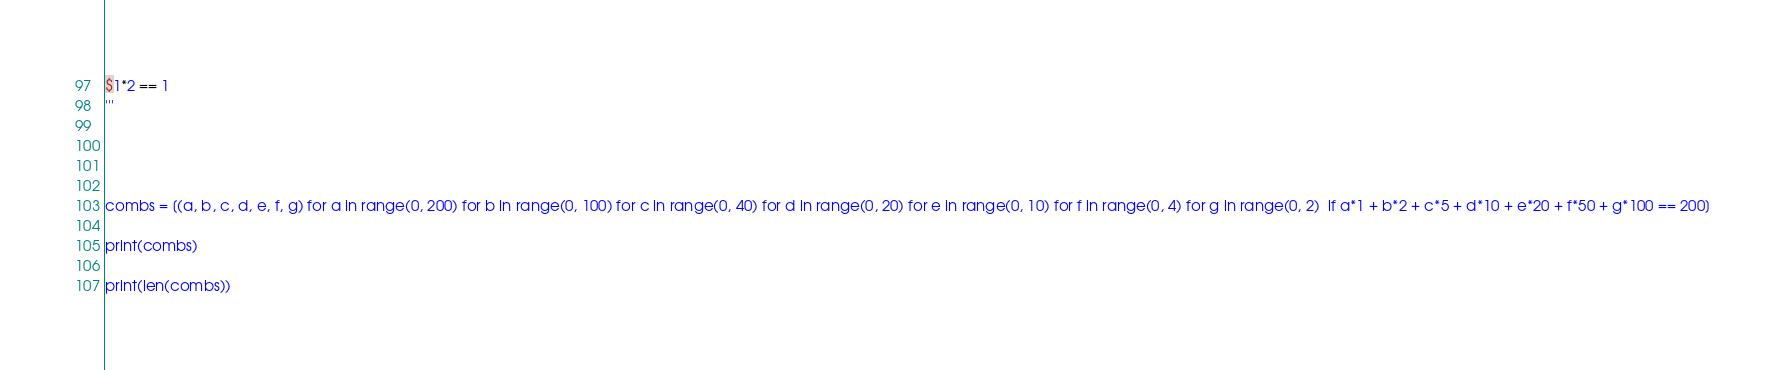<code> <loc_0><loc_0><loc_500><loc_500><_Python_>$1*2 == 1
'''




combs = [(a, b, c, d, e, f, g) for a in range(0, 200) for b in range(0, 100) for c in range(0, 40) for d in range(0, 20) for e in range(0, 10) for f in range(0, 4) for g in range(0, 2)  if a*1 + b*2 + c*5 + d*10 + e*20 + f*50 + g*100 == 200]

print(combs)

print(len(combs))</code> 